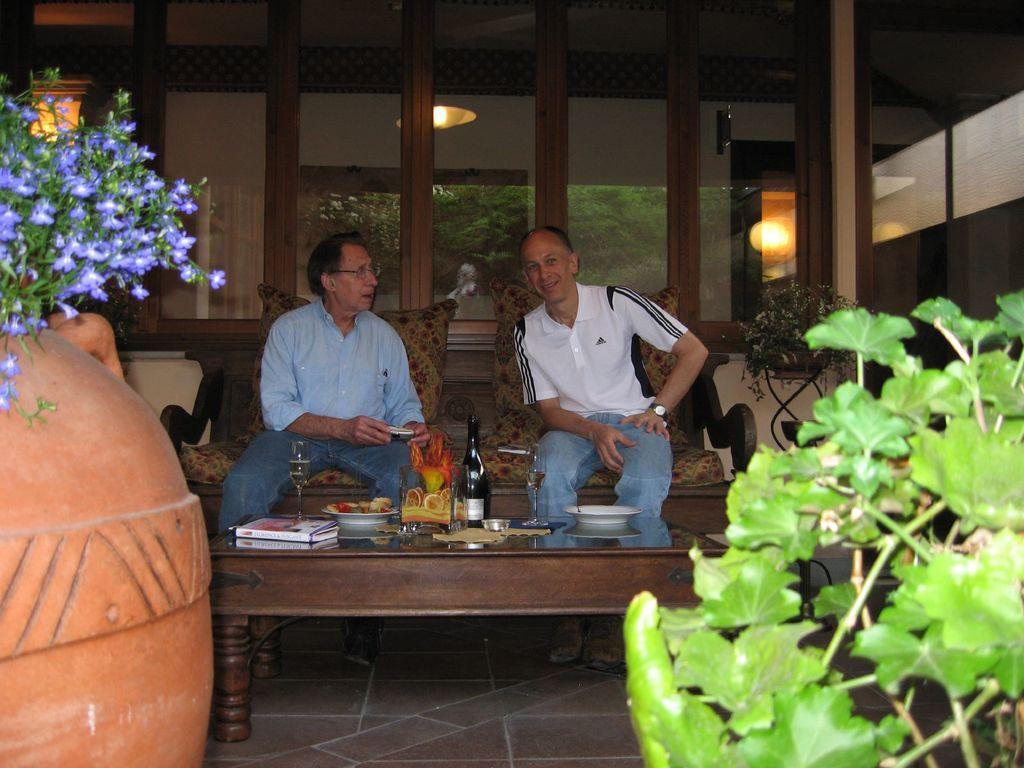Please provide a concise description of this image. Here we can see two men sitting on chairs with a table in front of them having a bottle of wine and bowls of fruits and books present on it and in the front we can see plants present 